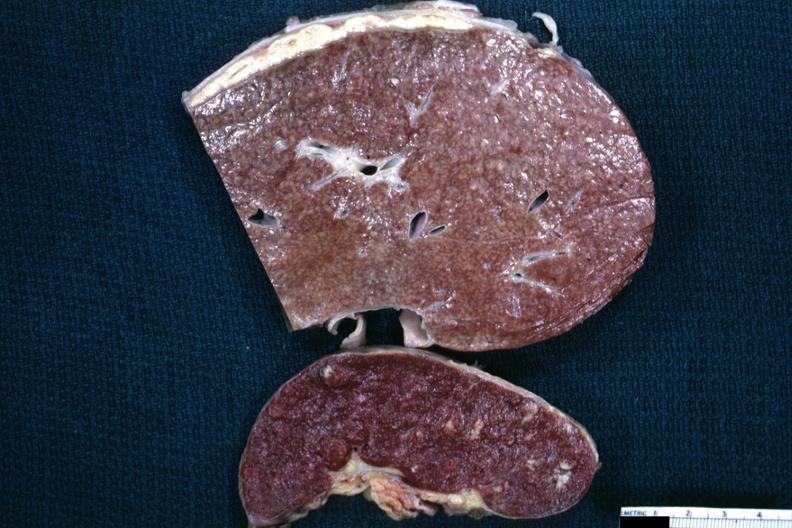s typical tuberculous exudate present on capsule of liver and spleen?
Answer the question using a single word or phrase. Yes 